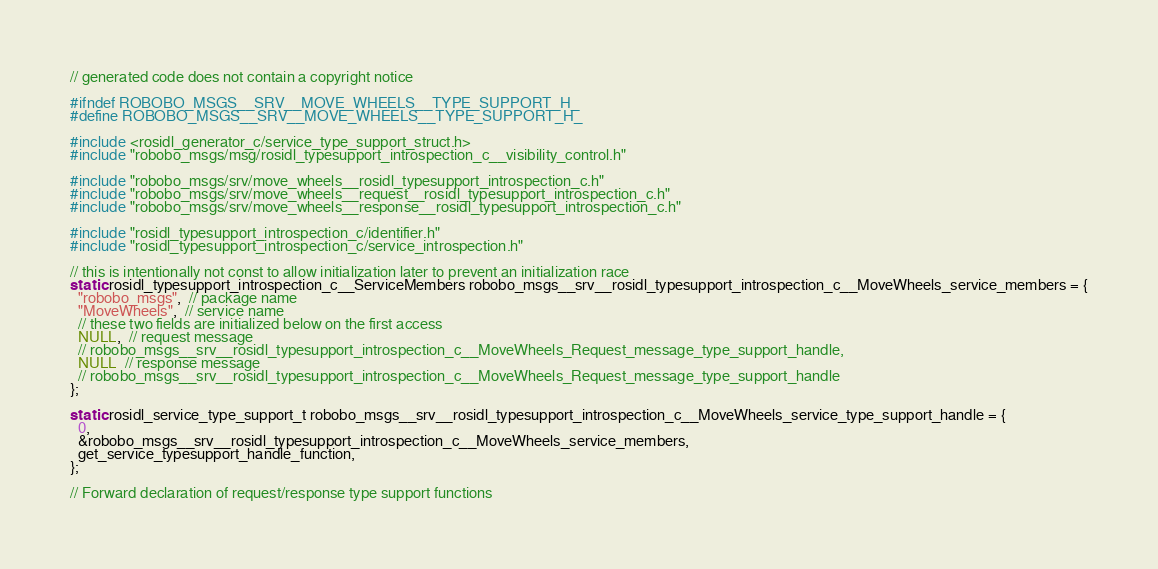Convert code to text. <code><loc_0><loc_0><loc_500><loc_500><_C_>// generated code does not contain a copyright notice

#ifndef ROBOBO_MSGS__SRV__MOVE_WHEELS__TYPE_SUPPORT_H_
#define ROBOBO_MSGS__SRV__MOVE_WHEELS__TYPE_SUPPORT_H_

#include <rosidl_generator_c/service_type_support_struct.h>
#include "robobo_msgs/msg/rosidl_typesupport_introspection_c__visibility_control.h"

#include "robobo_msgs/srv/move_wheels__rosidl_typesupport_introspection_c.h"
#include "robobo_msgs/srv/move_wheels__request__rosidl_typesupport_introspection_c.h"
#include "robobo_msgs/srv/move_wheels__response__rosidl_typesupport_introspection_c.h"

#include "rosidl_typesupport_introspection_c/identifier.h"
#include "rosidl_typesupport_introspection_c/service_introspection.h"

// this is intentionally not const to allow initialization later to prevent an initialization race
static rosidl_typesupport_introspection_c__ServiceMembers robobo_msgs__srv__rosidl_typesupport_introspection_c__MoveWheels_service_members = {
  "robobo_msgs",  // package name
  "MoveWheels",  // service name
  // these two fields are initialized below on the first access
  NULL,  // request message
  // robobo_msgs__srv__rosidl_typesupport_introspection_c__MoveWheels_Request_message_type_support_handle,
  NULL  // response message
  // robobo_msgs__srv__rosidl_typesupport_introspection_c__MoveWheels_Request_message_type_support_handle
};

static rosidl_service_type_support_t robobo_msgs__srv__rosidl_typesupport_introspection_c__MoveWheels_service_type_support_handle = {
  0,
  &robobo_msgs__srv__rosidl_typesupport_introspection_c__MoveWheels_service_members,
  get_service_typesupport_handle_function,
};

// Forward declaration of request/response type support functions</code> 